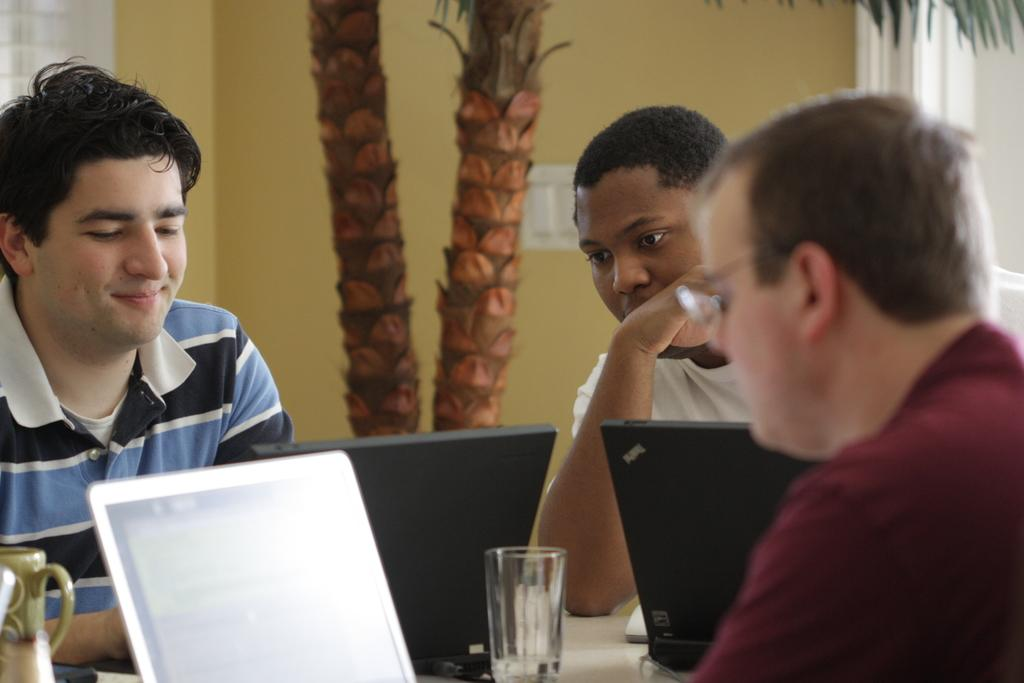What are the people in the image doing? The people in the image are seated. What objects can be seen on the table in the image? There are laptops and a glass on the table. What type of vegetation is visible in the image? There are trees visible in the image. What type of building is present in the image? There is a house in the image. What type of box is being used by the people in the image? There is no box present in the image; the people are using laptops and a glass on the table. 